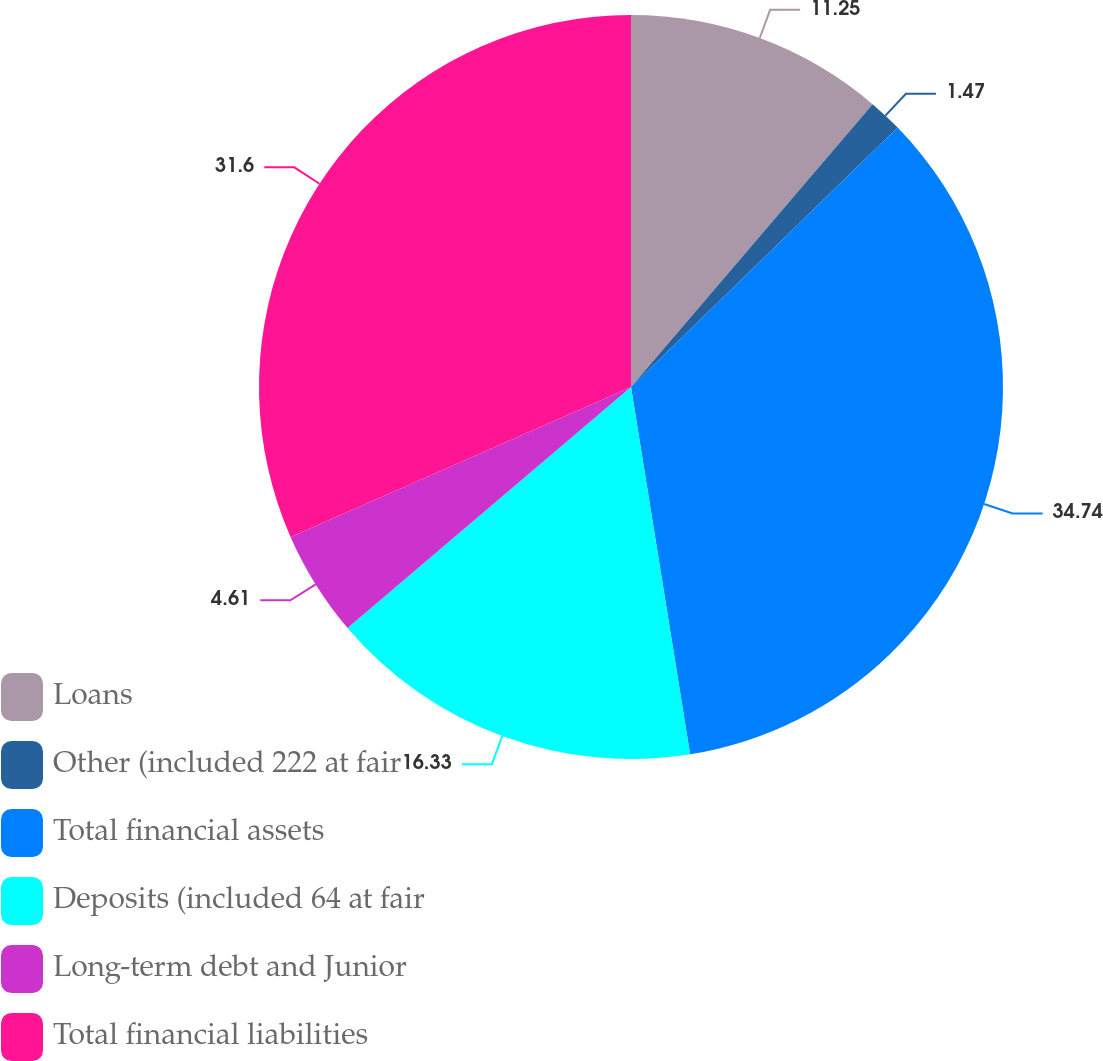Convert chart to OTSL. <chart><loc_0><loc_0><loc_500><loc_500><pie_chart><fcel>Loans<fcel>Other (included 222 at fair<fcel>Total financial assets<fcel>Deposits (included 64 at fair<fcel>Long-term debt and Junior<fcel>Total financial liabilities<nl><fcel>11.25%<fcel>1.47%<fcel>34.74%<fcel>16.33%<fcel>4.61%<fcel>31.6%<nl></chart> 